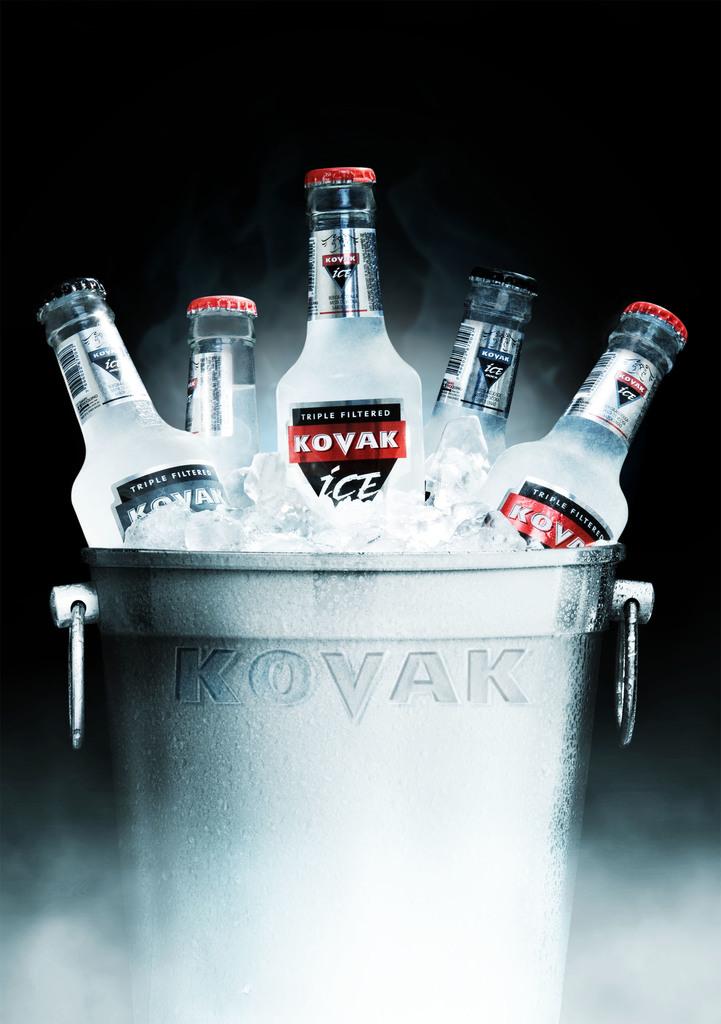How is this filtered?
Provide a succinct answer. Triple. What brand of drink is this?
Ensure brevity in your answer.  Kovak. 